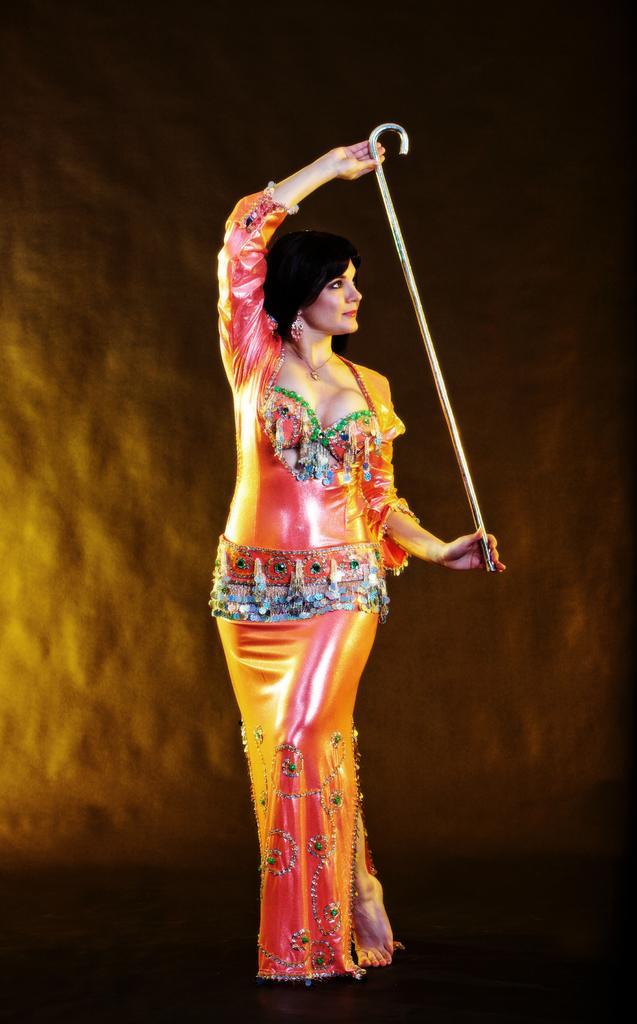Can you describe this image briefly? In this image I can see a woman is holding a stick in hand is standing on the ground. In the background I can see a stone wall. This image is taken may be during night. 